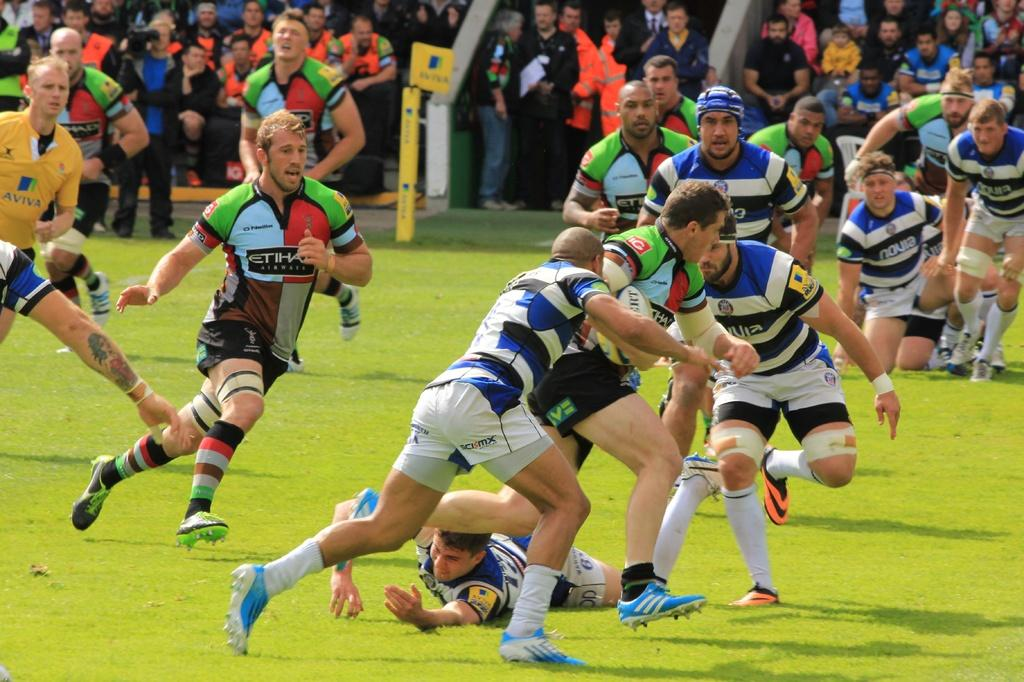<image>
Provide a brief description of the given image. A player in an Etihad Airways jersey runs to the ball during a heated rugby match. 